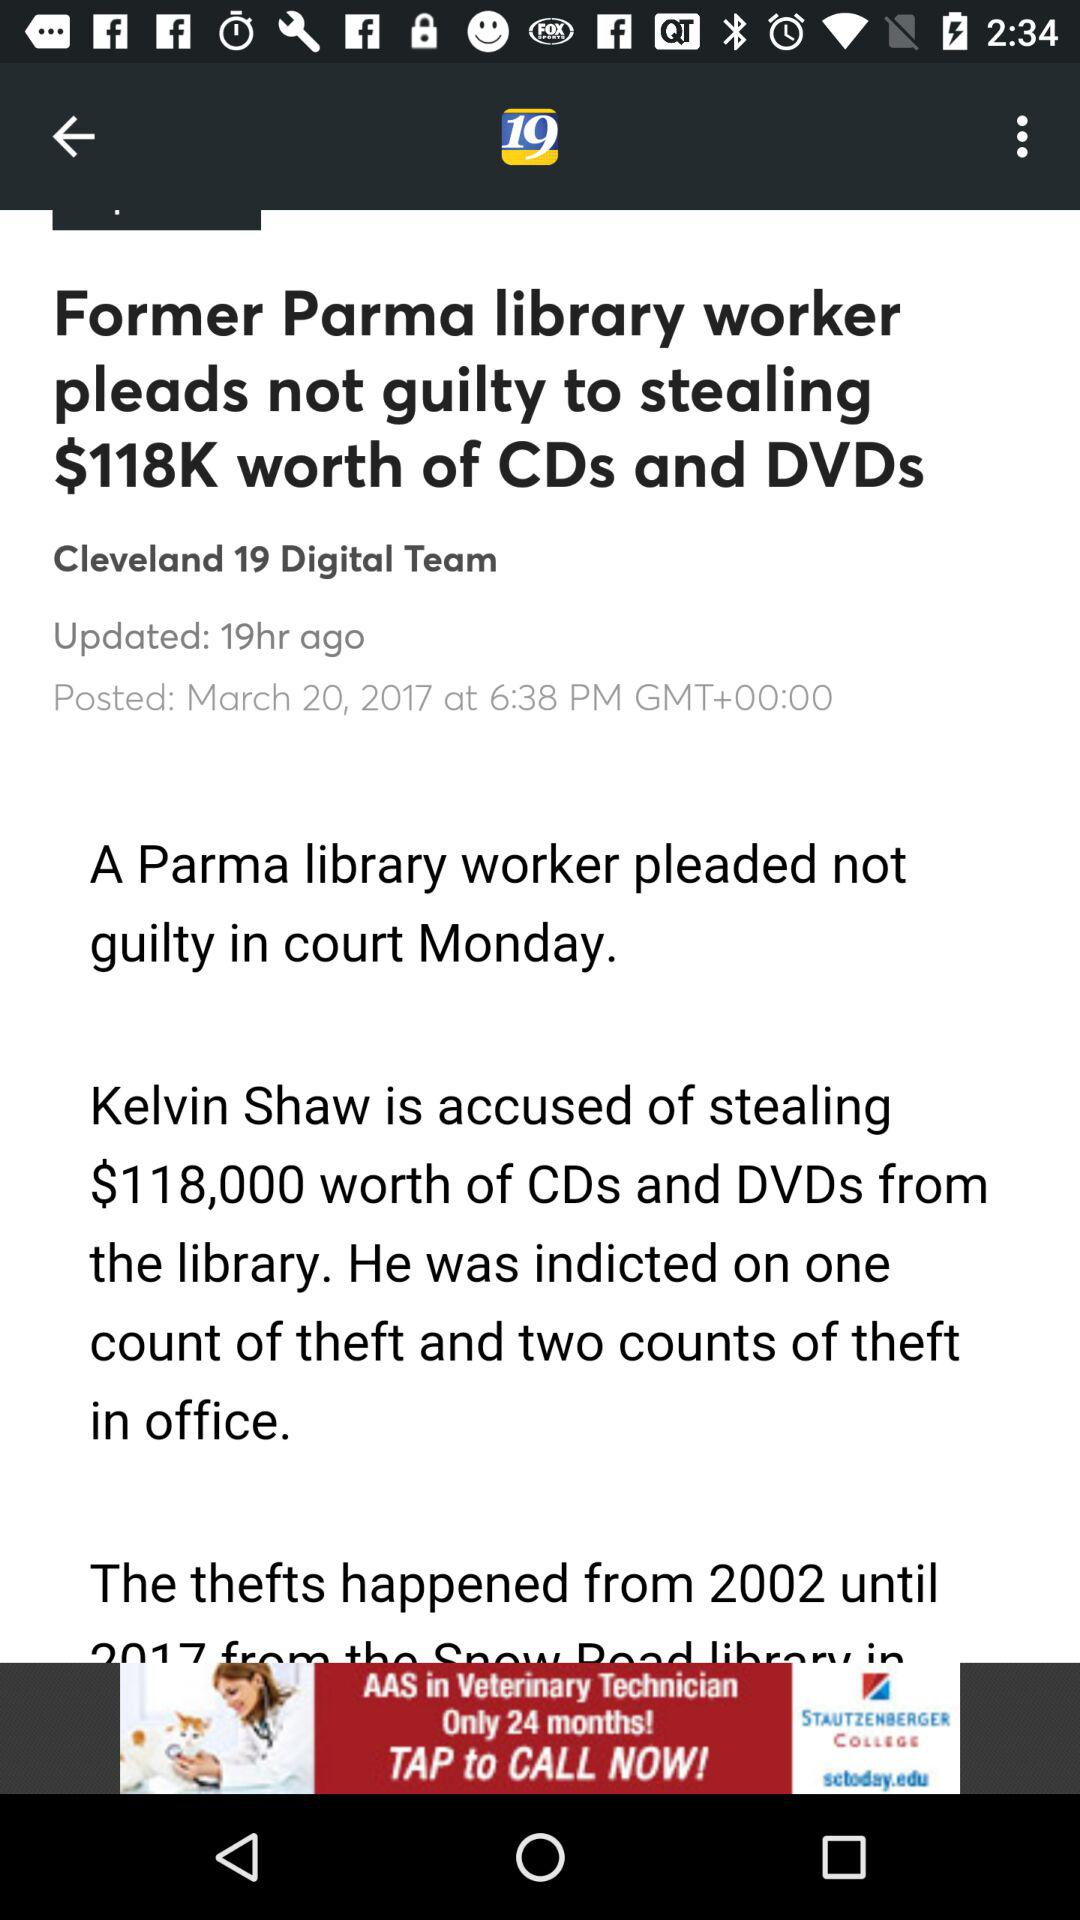Who published the article "Former Parma library worker pleads not guilty to stealing $118K worth of CDs and DVDs"? The article was published by the "Cleveland 19 Digital Team". 